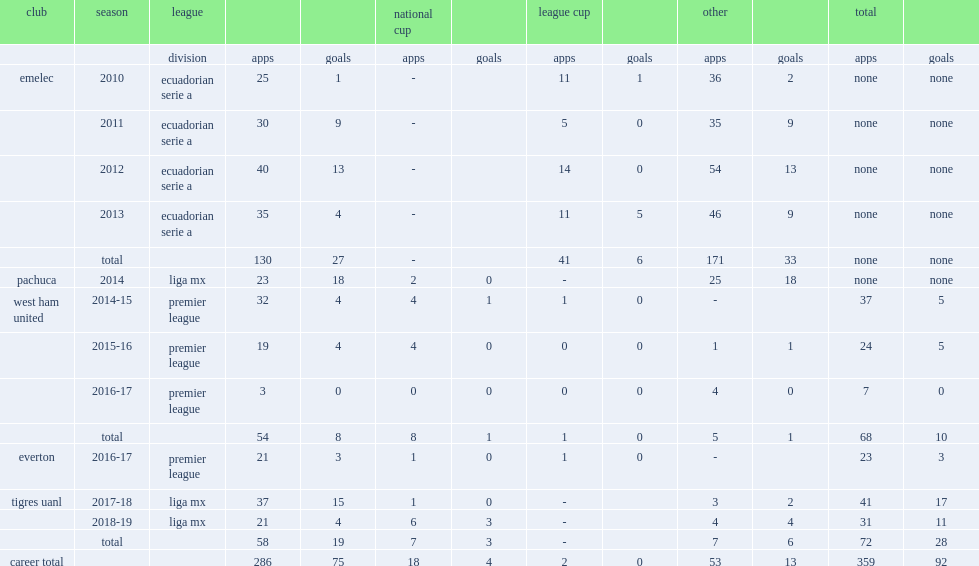Which club did enner valencia play for in 2014? Pachuca. 